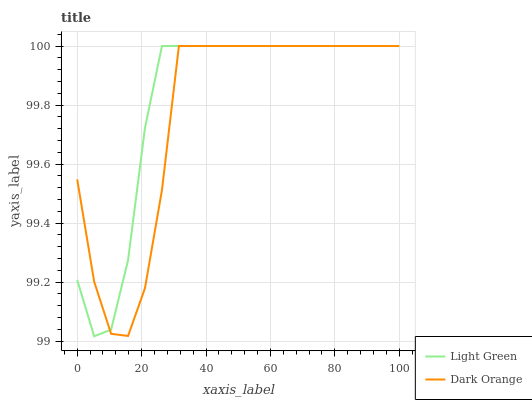Does Dark Orange have the minimum area under the curve?
Answer yes or no. Yes. Does Light Green have the maximum area under the curve?
Answer yes or no. Yes. Does Light Green have the minimum area under the curve?
Answer yes or no. No. Is Light Green the smoothest?
Answer yes or no. Yes. Is Dark Orange the roughest?
Answer yes or no. Yes. Is Light Green the roughest?
Answer yes or no. No. Does Light Green have the lowest value?
Answer yes or no. Yes. Does Light Green have the highest value?
Answer yes or no. Yes. Does Dark Orange intersect Light Green?
Answer yes or no. Yes. Is Dark Orange less than Light Green?
Answer yes or no. No. Is Dark Orange greater than Light Green?
Answer yes or no. No. 